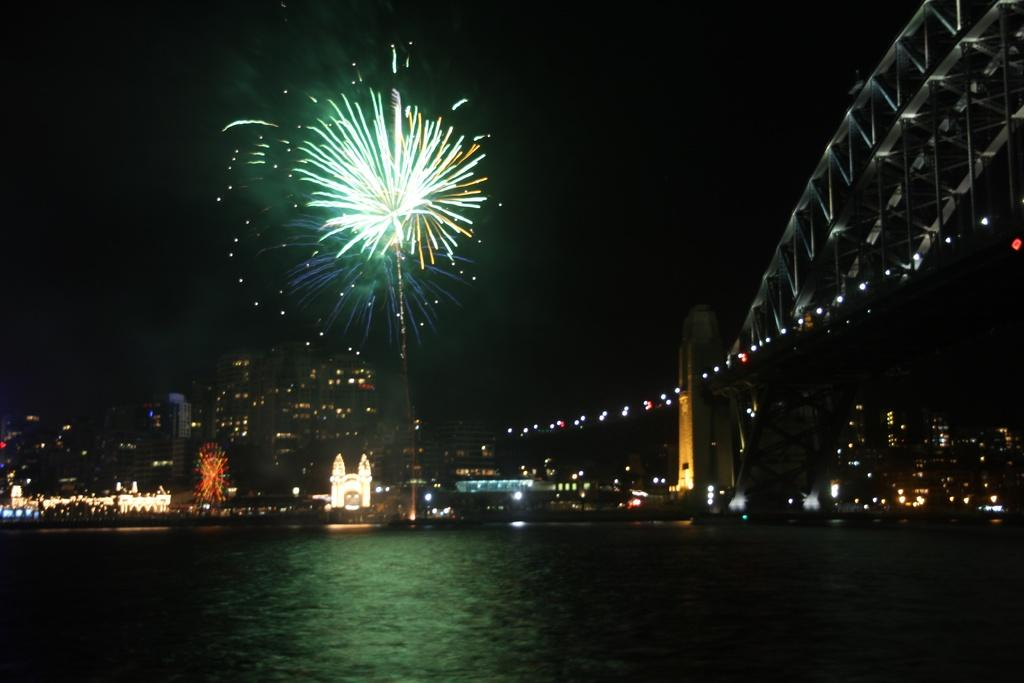What type of natural feature is present in the image? There is a river in the image. What type of structures can be seen in the background of the image? There are buildings and houses in the background of the image. What can be seen illuminating the background of the image? Lights are visible in the background of the image. How would you describe the overall lighting in the image? The image appears to be dark. How many toads can be seen swimming in the river in the image? There are no toads visible in the image; it only features a river, buildings, houses, and lights. What type of sea creature is present in the image? There are no sea creatures present in the image; it only features a river, buildings, houses, and lights. 